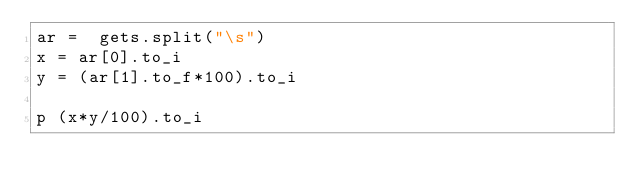<code> <loc_0><loc_0><loc_500><loc_500><_Ruby_>ar =  gets.split("\s")
x = ar[0].to_i
y = (ar[1].to_f*100).to_i

p (x*y/100).to_i
</code> 